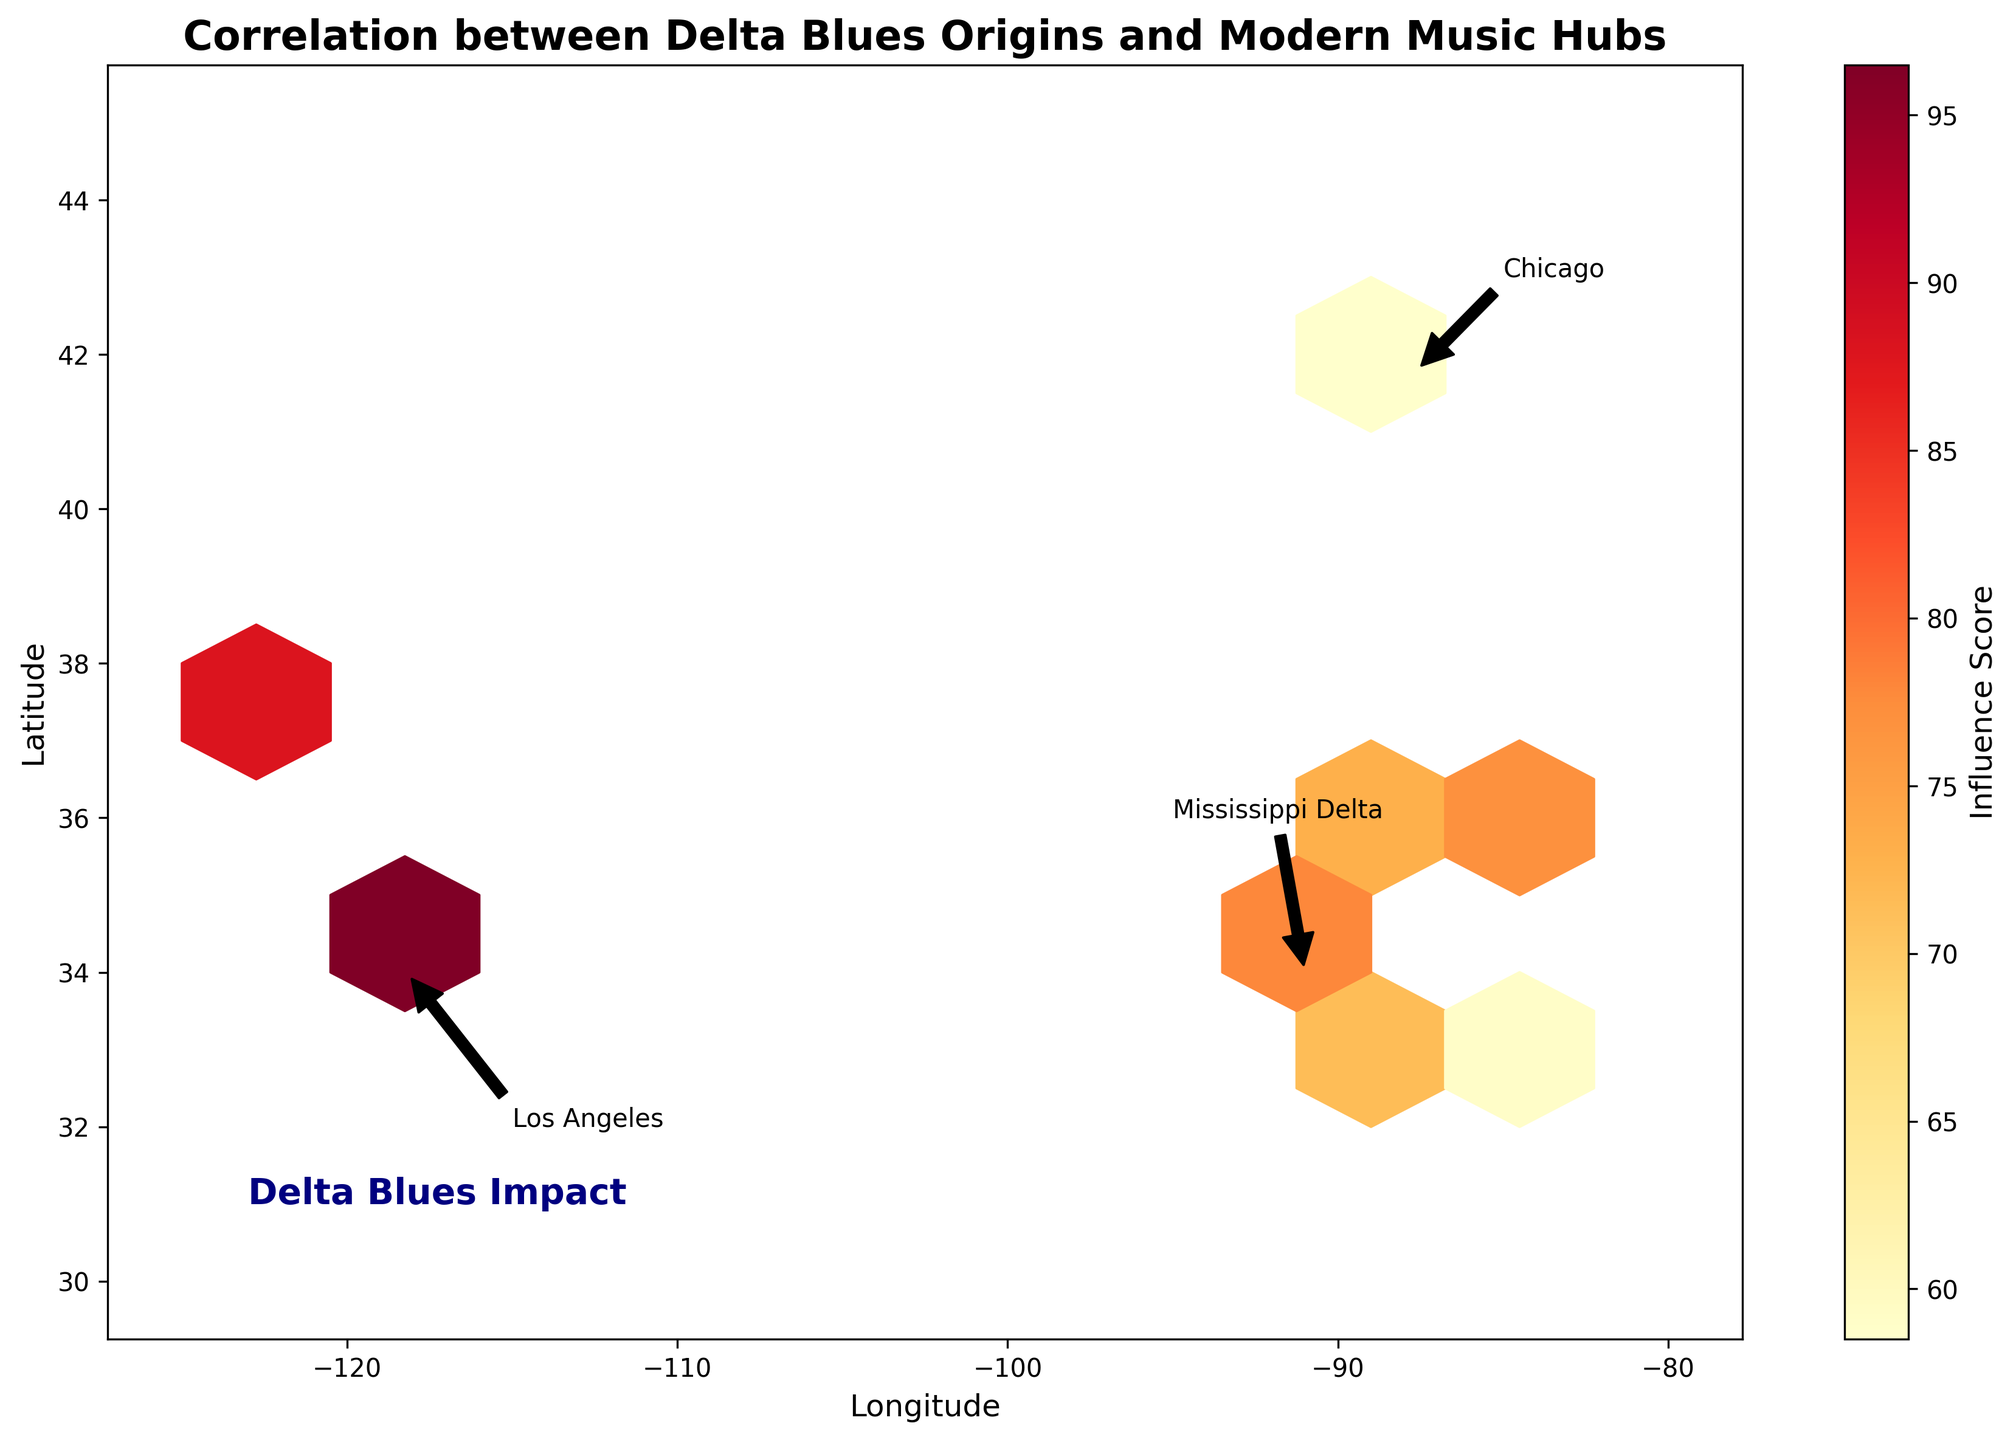What is the title of the plot? The title of the plot can be found at the top of the figure. The text reads "Correlation between Delta Blues Origins and Modern Music Hubs".
Answer: Correlation between Delta Blues Origins and Modern Music Hubs What do the x and y axes represent? The x-axis represents Longitude, and the y-axis represents Latitude. This can be observed from the labels on each axis.
Answer: Longitude and Latitude Which location has the highest influence score? By looking at the color bar and identifying the hexbin with the deepest color, the highest influence score is near Los Angeles, specifically around the coordinates (-118.2, 34.0).
Answer: Los Angeles What does the color of the hexagons represent? The color of the hexagons represents the Influence Score, with higher scores depicted in darker colors within the 'YlOrRd' colormap (Yellow to Orange to Red). This information is conveyed by both the color bar and the hexbin plot.
Answer: Influence Score Which cities are annotated in the plot? The plot includes annotations for three cities: Mississippi Delta, Chicago, and Los Angeles. This information is noted with text and arrows pointing to their respective locations.
Answer: Mississippi Delta, Chicago, Los Angeles Are there any hexagons with a high concentration in the Mississippi Delta region? By examining the hexagons around the coordinates approximately (-91, 34) and observing the density of color, it can be noted that the region has several densely colored hexagons.
Answer: Yes, there are several densely colored hexagons How does the influence score of locations around Mississippi Delta generally compare to those around Chicago? By comparing the color intensity around (-91, 34) for the Mississippi Delta and around (-87.6, 41.8) for Chicago, the influence scores in the Mississippi Delta tend to be lower compared to Chicago's higher concentrated hexagons.
Answer: Chicago has higher influence scores Which geographical region has more diverse influence scores, Delta Blues origins or modern music hubs? By observing the range of color intensities, Delta Blues origins near the Mississippi Delta have somewhat of a narrower range of influence scores compared to the diverse scores (from medium to very high) found in modern music hubs like Los Angeles and Chicago.
Answer: Modern music hubs What is the color of the hexagon at coordinates (34.5, -90.7) and what does this indicate about the influence score? Referencing the plot, the hexagon at these coordinates is a dark shade, indicative of a higher influence score. This can be cross-referenced with the color bar that associates darker colors with higher values.
Answer: Dark shade indicates a high influence score 